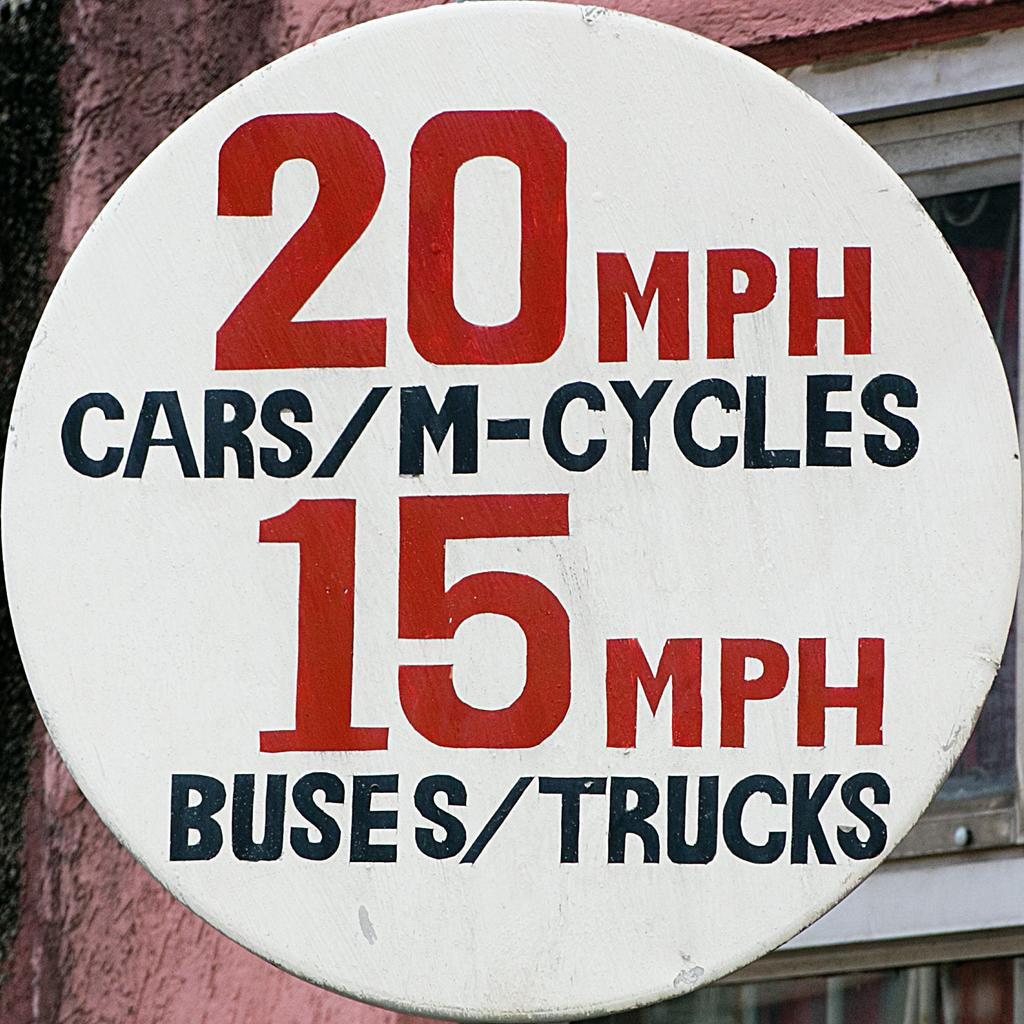<image>
Summarize the visual content of the image. 20 mph is the speed limit for cars and bicycles according to the sign. 